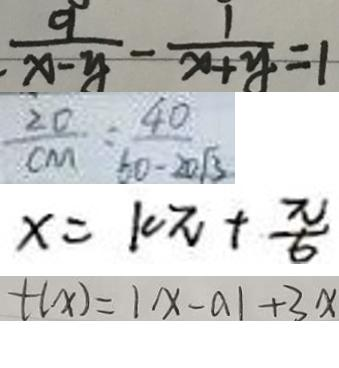Convert formula to latex. <formula><loc_0><loc_0><loc_500><loc_500>\frac { 9 } { x - y } - \frac { 1 } { x + y } = 1 
 \frac { 2 0 } { C M } = \frac { 4 0 } { 6 0 - 2 0 \sqrt { 3 } } 
 x = 1 0 \pi + \frac { \pi } { 6 } 
 t ( x ) = 1 x - a 1 + 3 x</formula> 